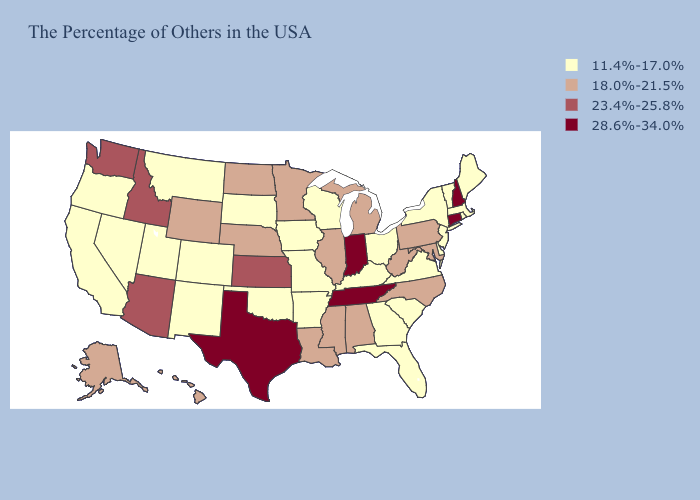Among the states that border South Dakota , does Montana have the lowest value?
Concise answer only. Yes. What is the lowest value in the Northeast?
Give a very brief answer. 11.4%-17.0%. Name the states that have a value in the range 28.6%-34.0%?
Write a very short answer. New Hampshire, Connecticut, Indiana, Tennessee, Texas. Name the states that have a value in the range 11.4%-17.0%?
Concise answer only. Maine, Massachusetts, Rhode Island, Vermont, New York, New Jersey, Delaware, Virginia, South Carolina, Ohio, Florida, Georgia, Kentucky, Wisconsin, Missouri, Arkansas, Iowa, Oklahoma, South Dakota, Colorado, New Mexico, Utah, Montana, Nevada, California, Oregon. What is the value of Alabama?
Be succinct. 18.0%-21.5%. What is the value of Hawaii?
Answer briefly. 18.0%-21.5%. Name the states that have a value in the range 28.6%-34.0%?
Short answer required. New Hampshire, Connecticut, Indiana, Tennessee, Texas. What is the lowest value in states that border Indiana?
Short answer required. 11.4%-17.0%. Among the states that border Illinois , does Indiana have the lowest value?
Short answer required. No. Name the states that have a value in the range 11.4%-17.0%?
Write a very short answer. Maine, Massachusetts, Rhode Island, Vermont, New York, New Jersey, Delaware, Virginia, South Carolina, Ohio, Florida, Georgia, Kentucky, Wisconsin, Missouri, Arkansas, Iowa, Oklahoma, South Dakota, Colorado, New Mexico, Utah, Montana, Nevada, California, Oregon. Is the legend a continuous bar?
Keep it brief. No. What is the highest value in the USA?
Concise answer only. 28.6%-34.0%. What is the value of Maine?
Answer briefly. 11.4%-17.0%. Name the states that have a value in the range 11.4%-17.0%?
Keep it brief. Maine, Massachusetts, Rhode Island, Vermont, New York, New Jersey, Delaware, Virginia, South Carolina, Ohio, Florida, Georgia, Kentucky, Wisconsin, Missouri, Arkansas, Iowa, Oklahoma, South Dakota, Colorado, New Mexico, Utah, Montana, Nevada, California, Oregon. 